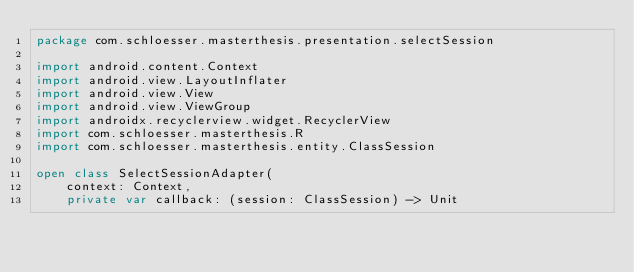Convert code to text. <code><loc_0><loc_0><loc_500><loc_500><_Kotlin_>package com.schloesser.masterthesis.presentation.selectSession

import android.content.Context
import android.view.LayoutInflater
import android.view.View
import android.view.ViewGroup
import androidx.recyclerview.widget.RecyclerView
import com.schloesser.masterthesis.R
import com.schloesser.masterthesis.entity.ClassSession

open class SelectSessionAdapter(
    context: Context,
    private var callback: (session: ClassSession) -> Unit</code> 